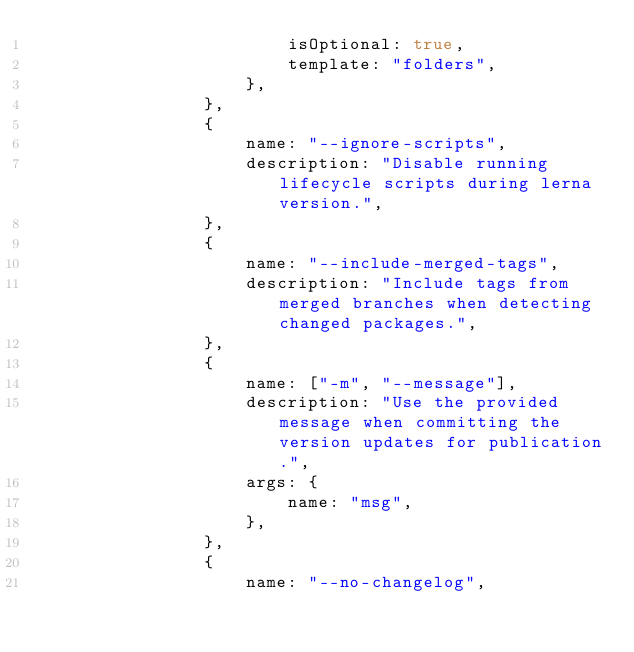Convert code to text. <code><loc_0><loc_0><loc_500><loc_500><_JavaScript_>                        isOptional: true,
                        template: "folders",
                    },
                },
                {
                    name: "--ignore-scripts",
                    description: "Disable running lifecycle scripts during lerna version.",
                },
                {
                    name: "--include-merged-tags",
                    description: "Include tags from merged branches when detecting changed packages.",
                },
                {
                    name: ["-m", "--message"],
                    description: "Use the provided message when committing the version updates for publication.",
                    args: {
                        name: "msg",
                    },
                },
                {
                    name: "--no-changelog",</code> 